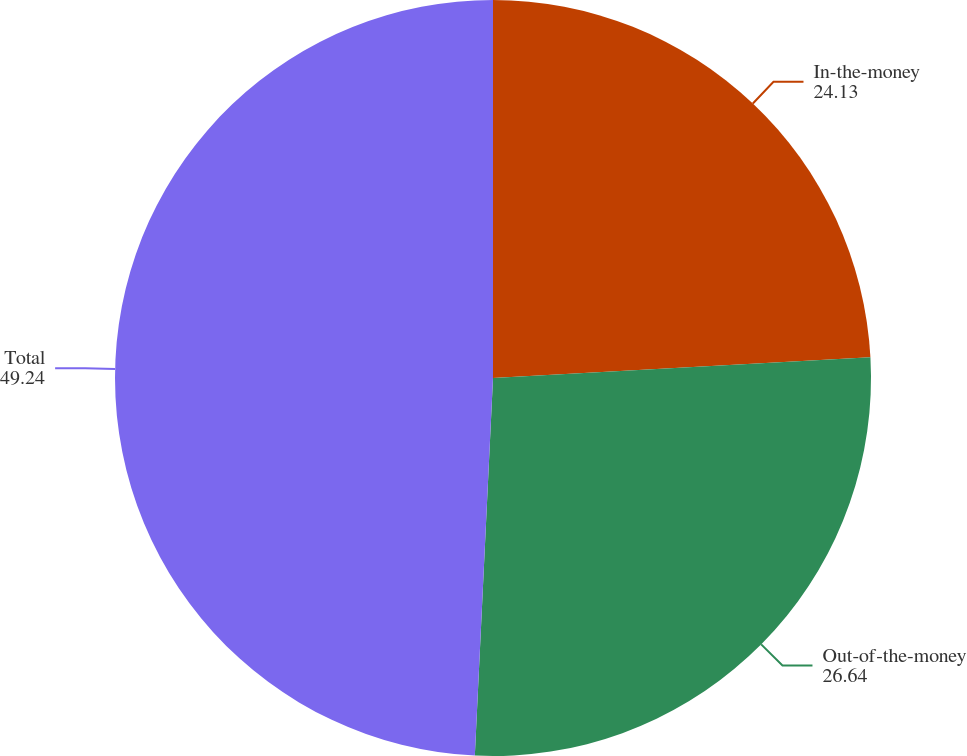Convert chart to OTSL. <chart><loc_0><loc_0><loc_500><loc_500><pie_chart><fcel>In-the-money<fcel>Out-of-the-money<fcel>Total<nl><fcel>24.13%<fcel>26.64%<fcel>49.24%<nl></chart> 